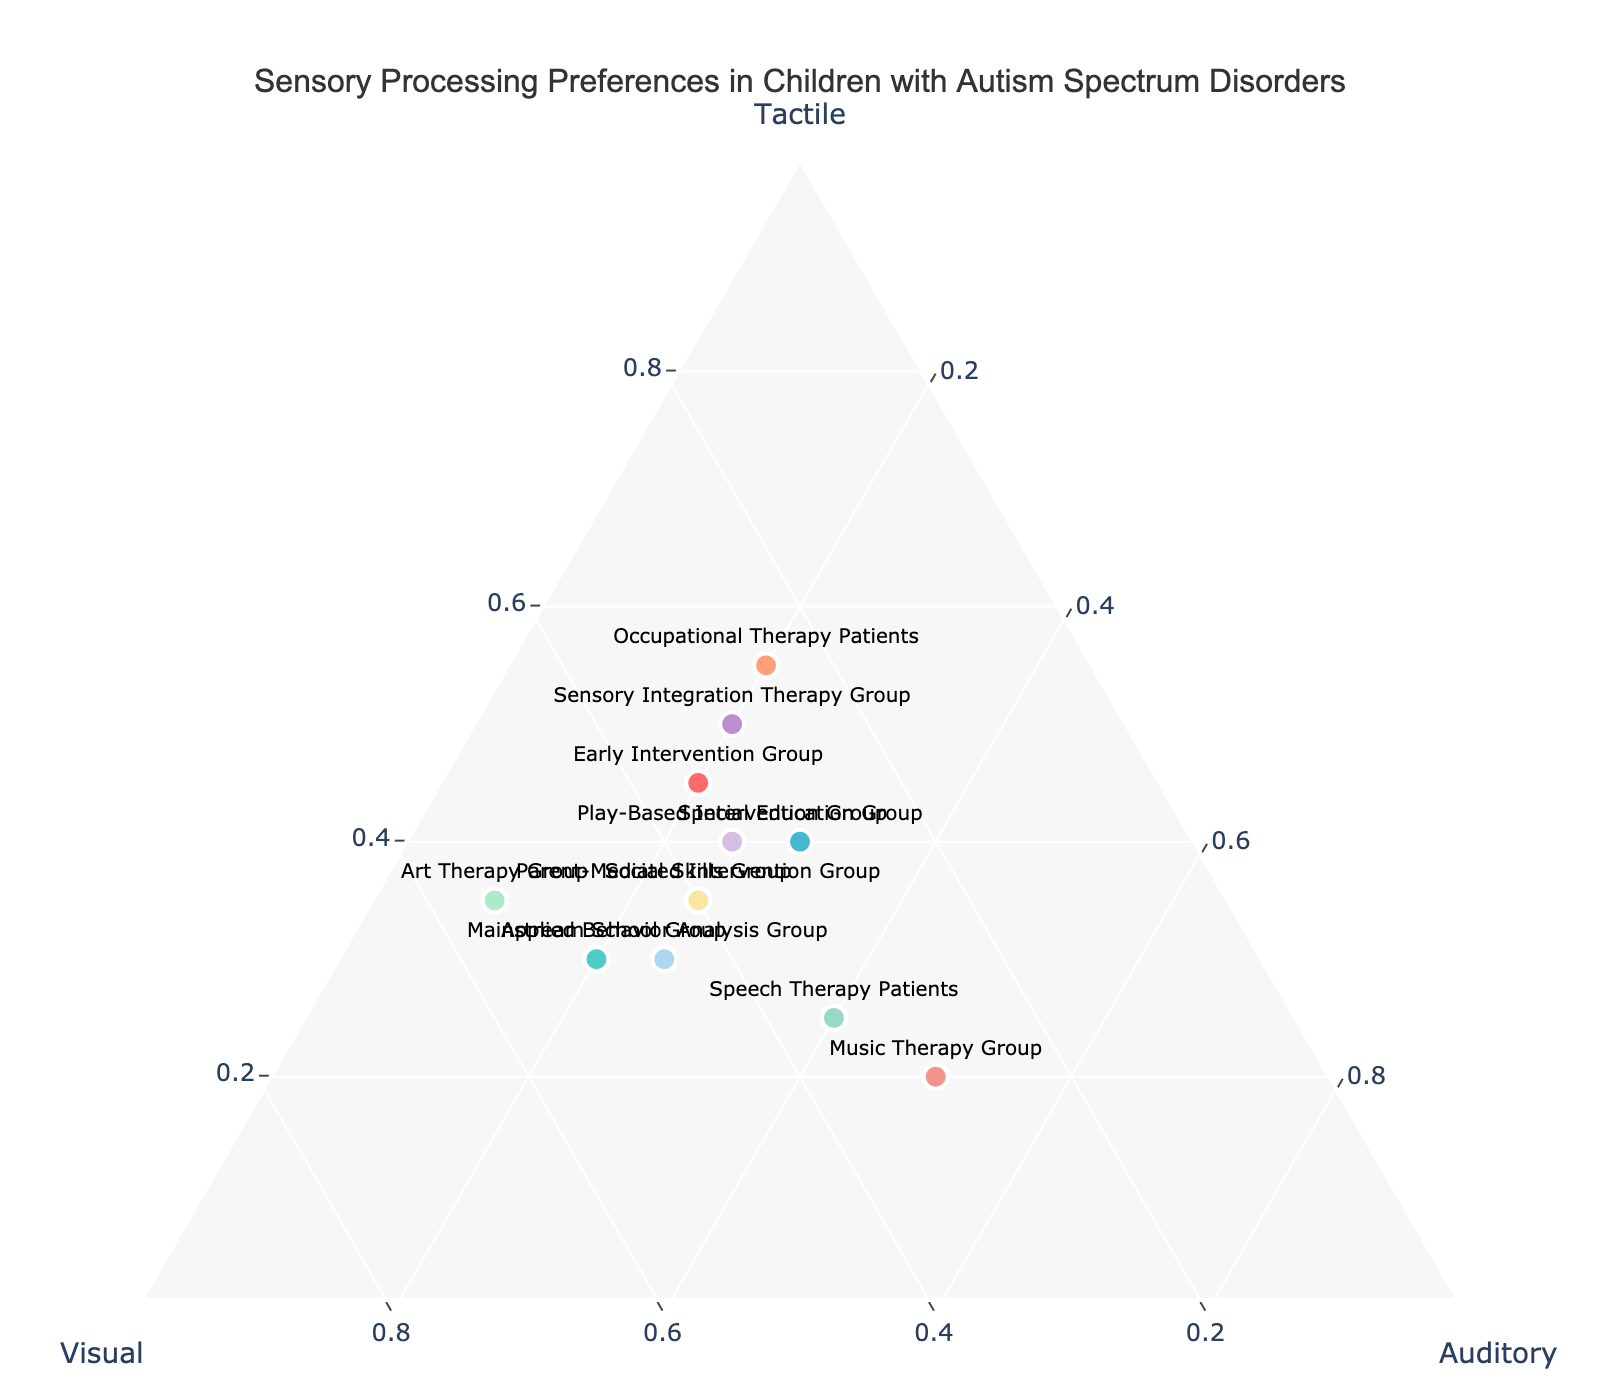What is the title of the figure? The title is located at the top center of the plot, which reads "Sensory Processing Preferences in Children with Autism Spectrum Disorders".
Answer: Sensory Processing Preferences in Children with Autism Spectrum Disorders How many groups are compared in this Ternary Plot? Count the number of data points present in the plot. Each point represents a group. There are 12 groups shown by the markers.
Answer: 12 Which group has the highest tactile processing preference? To find the group with the highest tactile percentage, observe the "Tactile" axis and look for the data point closest to 100%. The Occupational Therapy Patients group has the highest tactile value at 55%.
Answer: Occupational Therapy Patients Which group shows the lowest preference for auditory processing? Observe the "Auditory" axis and identify the data point closest to 0%. The Art Therapy Group shows the lowest preference for auditory processing with a value of 10%.
Answer: Art Therapy Group What is the average visual processing preference across all groups? Sum up the visual values (35 + 50 + 30 + 25 + 35 + 40 + 30 + 45 + 30 + 55 + 35 + 40) which equals 450, then divide by the number of groups: 450 / 12 = 37.5.
Answer: 37.5 Which groups have an equal percentage for auditory processing, and what is that percentage? Look for groups that share the same auditory percentage. Both Early Intervention Group, Mainstream School Group, Occupational Therapy Patients, Sensory Integration Therapy Group, and Applied Behavior Analysis Group have equal auditory processing percentages of 20%.
Answer: 20% What is the sum of tactile and visual preferences for the Special Education Group? For the Special Education Group, tactile is 40 and visual is 30. Sum them: 40 + 30 = 70.
Answer: 70 Which data point represents the Play-Based Intervention Group on the ternary plot? Refer to the legend or hover over the points in the plot to find the coordinates for the Play-Based Intervention Group. Its values are tactile = 40, visual = 35, and auditory = 25.
Answer: (40, 35, 25) How does the visual preference of the Art Therapy Group compare to the Play-Based Intervention Group? Compare the visual values: Art Therapy Group has 55, and Play-Based Intervention Group has 35. The Art Therapy Group has a higher visual preference.
Answer: Art Therapy Group has higher visual preference Which groups have equal tactile preferences and what are their values? Look for groups with equal tactile percentages. The Social Skills Group and Parent-Mediated Intervention Group each have 35% tactile preferences.
Answer: 35% 